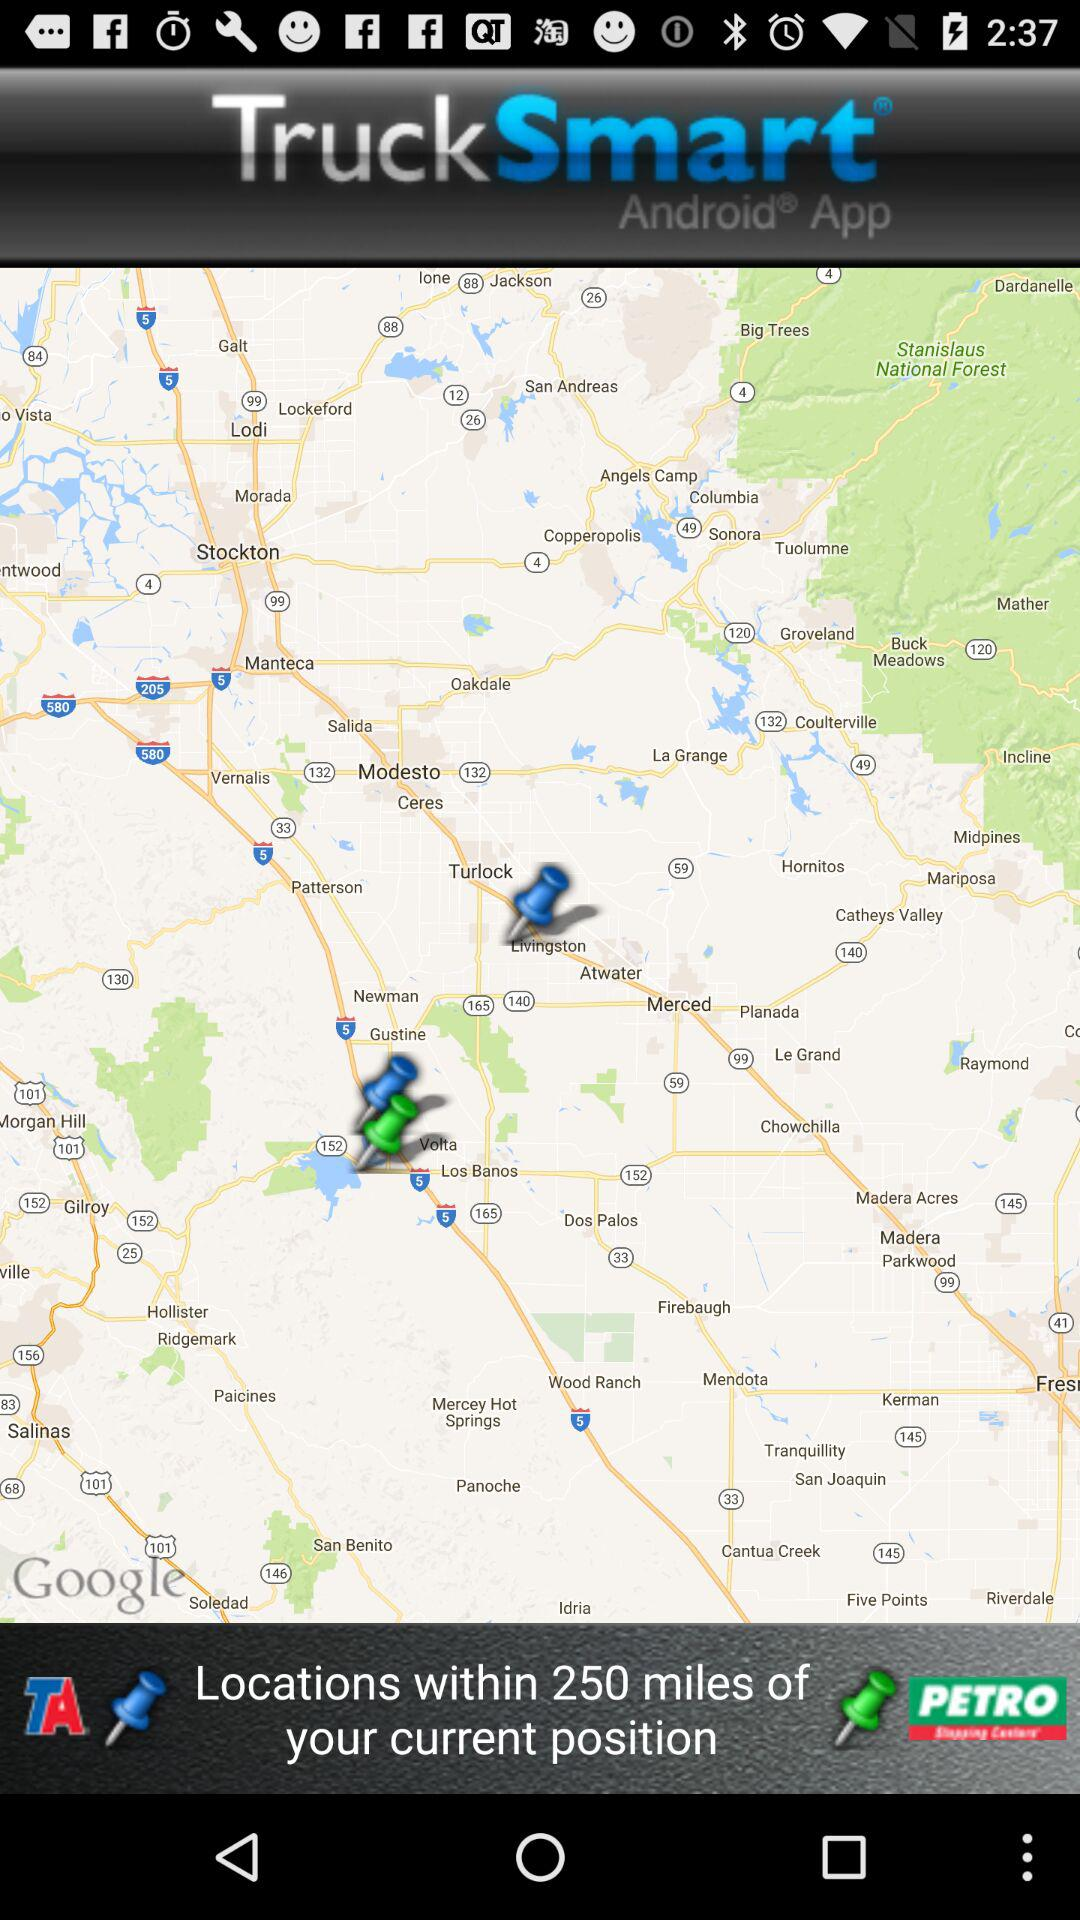What is the name of the application? The name of the application is "Truck Smart". 